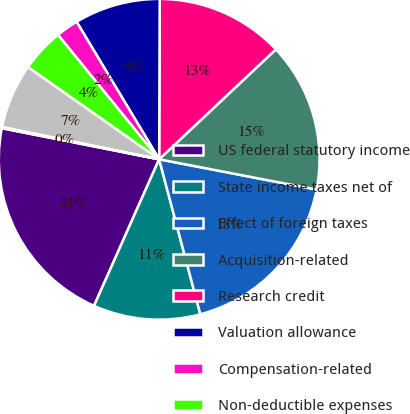<chart> <loc_0><loc_0><loc_500><loc_500><pie_chart><fcel>US federal statutory income<fcel>State income taxes net of<fcel>Effect of foreign taxes<fcel>Acquisition-related<fcel>Research credit<fcel>Valuation allowance<fcel>Compensation-related<fcel>Non-deductible expenses<fcel>Uncertain domestic tax<fcel>Other net<nl><fcel>21.45%<fcel>10.79%<fcel>17.84%<fcel>15.05%<fcel>12.92%<fcel>8.66%<fcel>2.26%<fcel>4.39%<fcel>6.52%<fcel>0.12%<nl></chart> 